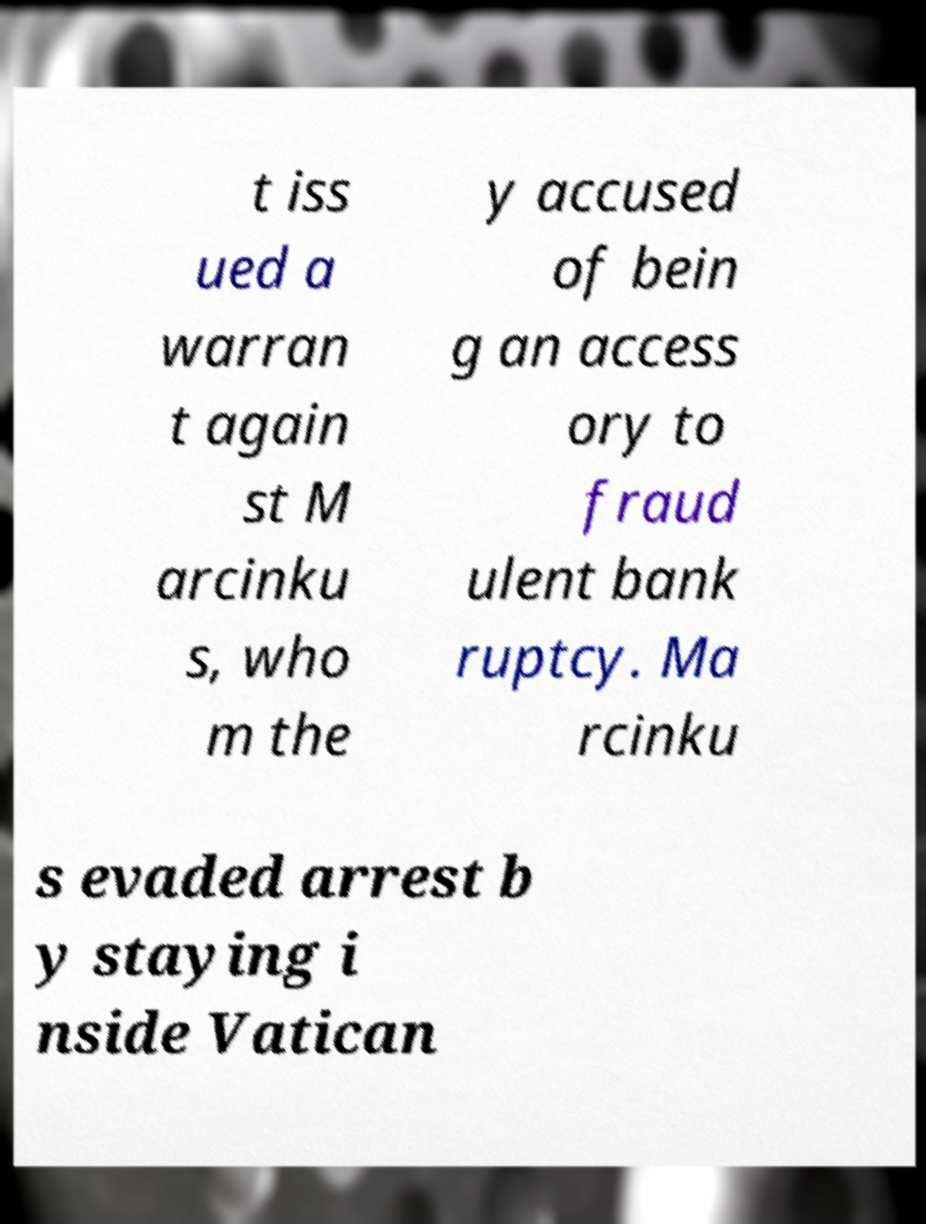Please identify and transcribe the text found in this image. t iss ued a warran t again st M arcinku s, who m the y accused of bein g an access ory to fraud ulent bank ruptcy. Ma rcinku s evaded arrest b y staying i nside Vatican 